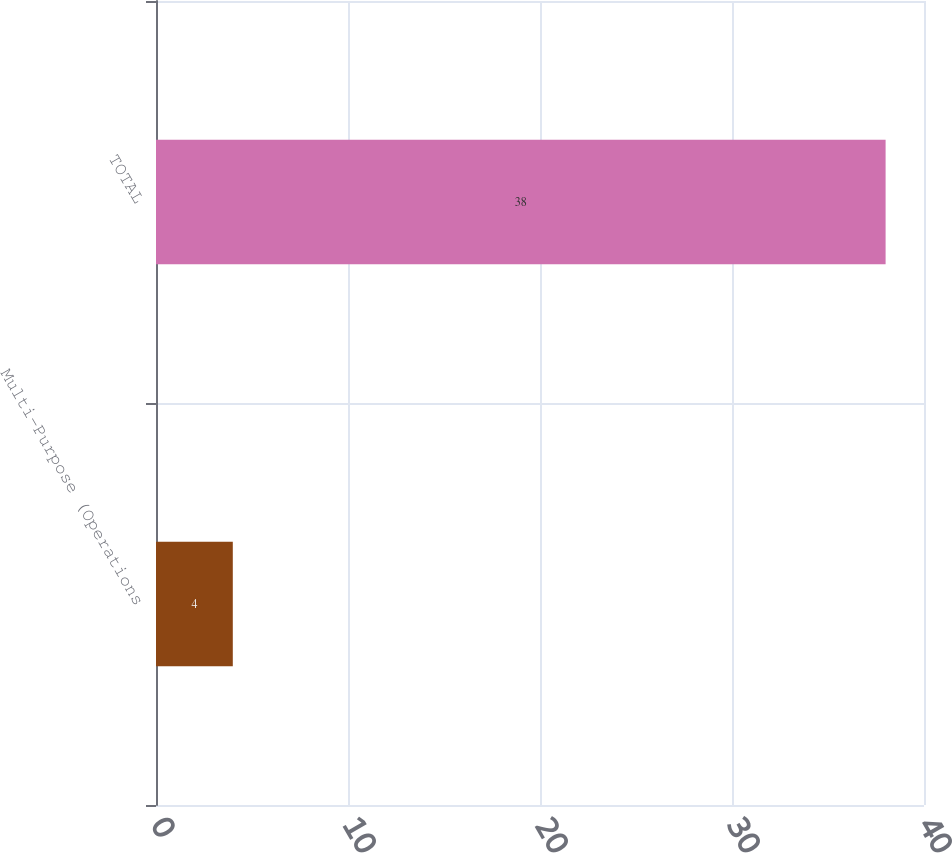Convert chart. <chart><loc_0><loc_0><loc_500><loc_500><bar_chart><fcel>Multi-Purpose (Operations<fcel>TOTAL<nl><fcel>4<fcel>38<nl></chart> 